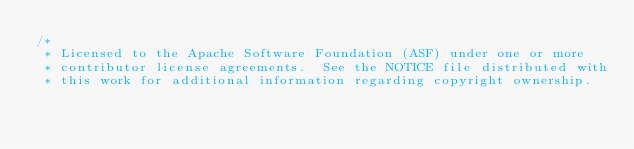Convert code to text. <code><loc_0><loc_0><loc_500><loc_500><_Java_>/*
 * Licensed to the Apache Software Foundation (ASF) under one or more
 * contributor license agreements.  See the NOTICE file distributed with
 * this work for additional information regarding copyright ownership.</code> 